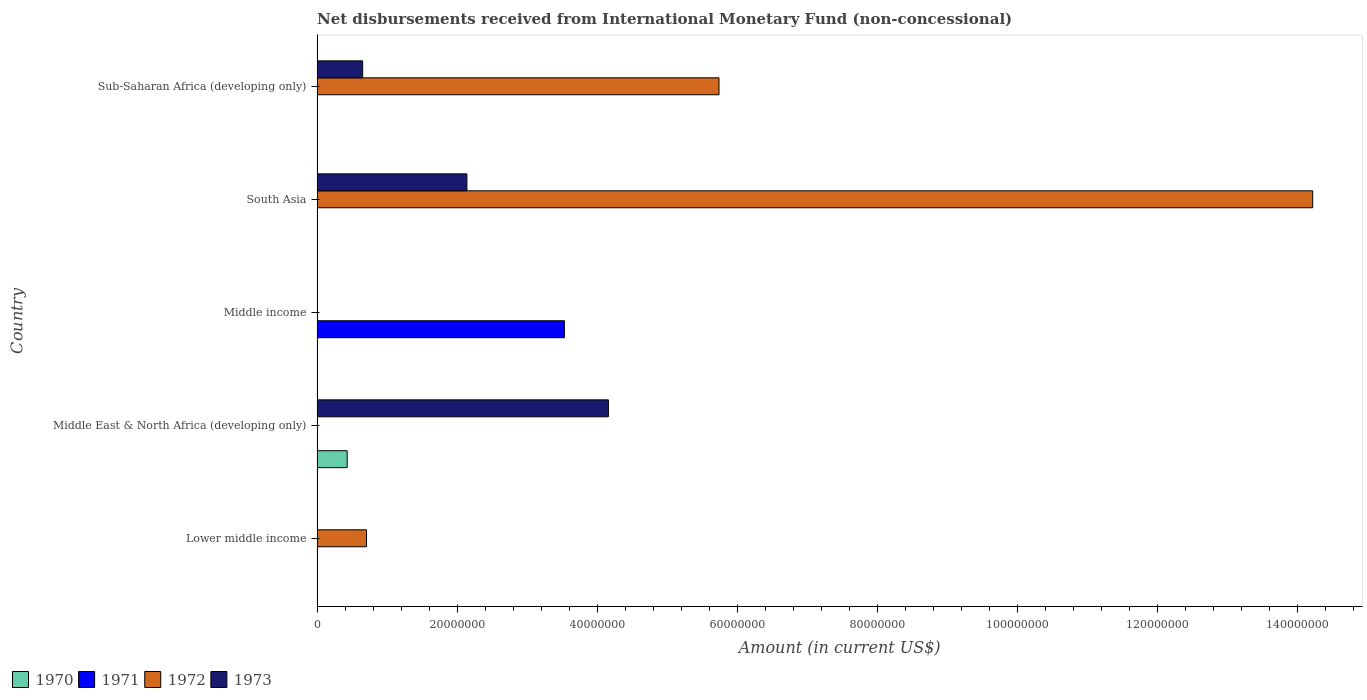How many different coloured bars are there?
Offer a terse response. 4. Are the number of bars per tick equal to the number of legend labels?
Provide a short and direct response. No. Are the number of bars on each tick of the Y-axis equal?
Offer a terse response. No. How many bars are there on the 1st tick from the bottom?
Give a very brief answer. 1. What is the label of the 4th group of bars from the top?
Ensure brevity in your answer.  Middle East & North Africa (developing only). In how many cases, is the number of bars for a given country not equal to the number of legend labels?
Ensure brevity in your answer.  5. What is the amount of disbursements received from International Monetary Fund in 1972 in South Asia?
Your answer should be very brief. 1.42e+08. Across all countries, what is the maximum amount of disbursements received from International Monetary Fund in 1972?
Provide a succinct answer. 1.42e+08. In which country was the amount of disbursements received from International Monetary Fund in 1973 maximum?
Ensure brevity in your answer.  Middle East & North Africa (developing only). What is the total amount of disbursements received from International Monetary Fund in 1972 in the graph?
Give a very brief answer. 2.07e+08. What is the difference between the amount of disbursements received from International Monetary Fund in 1972 in Lower middle income and that in Sub-Saharan Africa (developing only)?
Ensure brevity in your answer.  -5.03e+07. What is the difference between the amount of disbursements received from International Monetary Fund in 1973 in Middle income and the amount of disbursements received from International Monetary Fund in 1970 in Middle East & North Africa (developing only)?
Offer a very short reply. -4.30e+06. What is the average amount of disbursements received from International Monetary Fund in 1970 per country?
Make the answer very short. 8.60e+05. What is the difference between the amount of disbursements received from International Monetary Fund in 1972 and amount of disbursements received from International Monetary Fund in 1973 in South Asia?
Offer a terse response. 1.21e+08. In how many countries, is the amount of disbursements received from International Monetary Fund in 1970 greater than 80000000 US$?
Provide a succinct answer. 0. What is the ratio of the amount of disbursements received from International Monetary Fund in 1972 in Lower middle income to that in Sub-Saharan Africa (developing only)?
Your answer should be compact. 0.12. Is the amount of disbursements received from International Monetary Fund in 1973 in Middle East & North Africa (developing only) less than that in Sub-Saharan Africa (developing only)?
Give a very brief answer. No. What is the difference between the highest and the second highest amount of disbursements received from International Monetary Fund in 1972?
Make the answer very short. 8.48e+07. What is the difference between the highest and the lowest amount of disbursements received from International Monetary Fund in 1972?
Provide a succinct answer. 1.42e+08. In how many countries, is the amount of disbursements received from International Monetary Fund in 1971 greater than the average amount of disbursements received from International Monetary Fund in 1971 taken over all countries?
Provide a succinct answer. 1. Is it the case that in every country, the sum of the amount of disbursements received from International Monetary Fund in 1971 and amount of disbursements received from International Monetary Fund in 1970 is greater than the sum of amount of disbursements received from International Monetary Fund in 1973 and amount of disbursements received from International Monetary Fund in 1972?
Your answer should be compact. No. How many bars are there?
Keep it short and to the point. 8. Are all the bars in the graph horizontal?
Your answer should be very brief. Yes. What is the difference between two consecutive major ticks on the X-axis?
Provide a short and direct response. 2.00e+07. Are the values on the major ticks of X-axis written in scientific E-notation?
Ensure brevity in your answer.  No. Where does the legend appear in the graph?
Your answer should be very brief. Bottom left. How many legend labels are there?
Keep it short and to the point. 4. What is the title of the graph?
Give a very brief answer. Net disbursements received from International Monetary Fund (non-concessional). What is the label or title of the X-axis?
Provide a short and direct response. Amount (in current US$). What is the label or title of the Y-axis?
Your answer should be very brief. Country. What is the Amount (in current US$) of 1970 in Lower middle income?
Offer a very short reply. 0. What is the Amount (in current US$) of 1971 in Lower middle income?
Offer a terse response. 0. What is the Amount (in current US$) in 1972 in Lower middle income?
Offer a terse response. 7.06e+06. What is the Amount (in current US$) in 1970 in Middle East & North Africa (developing only)?
Offer a very short reply. 4.30e+06. What is the Amount (in current US$) of 1972 in Middle East & North Africa (developing only)?
Your answer should be very brief. 0. What is the Amount (in current US$) of 1973 in Middle East & North Africa (developing only)?
Your answer should be very brief. 4.16e+07. What is the Amount (in current US$) of 1970 in Middle income?
Offer a terse response. 0. What is the Amount (in current US$) in 1971 in Middle income?
Make the answer very short. 3.53e+07. What is the Amount (in current US$) in 1970 in South Asia?
Offer a very short reply. 0. What is the Amount (in current US$) in 1971 in South Asia?
Offer a terse response. 0. What is the Amount (in current US$) of 1972 in South Asia?
Ensure brevity in your answer.  1.42e+08. What is the Amount (in current US$) in 1973 in South Asia?
Your response must be concise. 2.14e+07. What is the Amount (in current US$) of 1972 in Sub-Saharan Africa (developing only)?
Provide a succinct answer. 5.74e+07. What is the Amount (in current US$) of 1973 in Sub-Saharan Africa (developing only)?
Keep it short and to the point. 6.51e+06. Across all countries, what is the maximum Amount (in current US$) in 1970?
Provide a succinct answer. 4.30e+06. Across all countries, what is the maximum Amount (in current US$) in 1971?
Keep it short and to the point. 3.53e+07. Across all countries, what is the maximum Amount (in current US$) of 1972?
Give a very brief answer. 1.42e+08. Across all countries, what is the maximum Amount (in current US$) in 1973?
Offer a terse response. 4.16e+07. Across all countries, what is the minimum Amount (in current US$) of 1972?
Offer a terse response. 0. What is the total Amount (in current US$) of 1970 in the graph?
Keep it short and to the point. 4.30e+06. What is the total Amount (in current US$) in 1971 in the graph?
Your response must be concise. 3.53e+07. What is the total Amount (in current US$) in 1972 in the graph?
Keep it short and to the point. 2.07e+08. What is the total Amount (in current US$) of 1973 in the graph?
Offer a very short reply. 6.95e+07. What is the difference between the Amount (in current US$) of 1972 in Lower middle income and that in South Asia?
Offer a terse response. -1.35e+08. What is the difference between the Amount (in current US$) in 1972 in Lower middle income and that in Sub-Saharan Africa (developing only)?
Your answer should be compact. -5.03e+07. What is the difference between the Amount (in current US$) in 1973 in Middle East & North Africa (developing only) and that in South Asia?
Make the answer very short. 2.02e+07. What is the difference between the Amount (in current US$) of 1973 in Middle East & North Africa (developing only) and that in Sub-Saharan Africa (developing only)?
Give a very brief answer. 3.51e+07. What is the difference between the Amount (in current US$) of 1972 in South Asia and that in Sub-Saharan Africa (developing only)?
Ensure brevity in your answer.  8.48e+07. What is the difference between the Amount (in current US$) of 1973 in South Asia and that in Sub-Saharan Africa (developing only)?
Ensure brevity in your answer.  1.49e+07. What is the difference between the Amount (in current US$) of 1972 in Lower middle income and the Amount (in current US$) of 1973 in Middle East & North Africa (developing only)?
Offer a terse response. -3.45e+07. What is the difference between the Amount (in current US$) of 1972 in Lower middle income and the Amount (in current US$) of 1973 in South Asia?
Offer a terse response. -1.43e+07. What is the difference between the Amount (in current US$) in 1972 in Lower middle income and the Amount (in current US$) in 1973 in Sub-Saharan Africa (developing only)?
Your answer should be compact. 5.46e+05. What is the difference between the Amount (in current US$) of 1970 in Middle East & North Africa (developing only) and the Amount (in current US$) of 1971 in Middle income?
Offer a terse response. -3.10e+07. What is the difference between the Amount (in current US$) of 1970 in Middle East & North Africa (developing only) and the Amount (in current US$) of 1972 in South Asia?
Keep it short and to the point. -1.38e+08. What is the difference between the Amount (in current US$) of 1970 in Middle East & North Africa (developing only) and the Amount (in current US$) of 1973 in South Asia?
Provide a succinct answer. -1.71e+07. What is the difference between the Amount (in current US$) in 1970 in Middle East & North Africa (developing only) and the Amount (in current US$) in 1972 in Sub-Saharan Africa (developing only)?
Your answer should be very brief. -5.31e+07. What is the difference between the Amount (in current US$) of 1970 in Middle East & North Africa (developing only) and the Amount (in current US$) of 1973 in Sub-Saharan Africa (developing only)?
Provide a short and direct response. -2.21e+06. What is the difference between the Amount (in current US$) in 1971 in Middle income and the Amount (in current US$) in 1972 in South Asia?
Give a very brief answer. -1.07e+08. What is the difference between the Amount (in current US$) of 1971 in Middle income and the Amount (in current US$) of 1973 in South Asia?
Offer a very short reply. 1.39e+07. What is the difference between the Amount (in current US$) in 1971 in Middle income and the Amount (in current US$) in 1972 in Sub-Saharan Africa (developing only)?
Offer a terse response. -2.21e+07. What is the difference between the Amount (in current US$) in 1971 in Middle income and the Amount (in current US$) in 1973 in Sub-Saharan Africa (developing only)?
Offer a very short reply. 2.88e+07. What is the difference between the Amount (in current US$) of 1972 in South Asia and the Amount (in current US$) of 1973 in Sub-Saharan Africa (developing only)?
Provide a short and direct response. 1.36e+08. What is the average Amount (in current US$) of 1970 per country?
Your answer should be very brief. 8.60e+05. What is the average Amount (in current US$) of 1971 per country?
Your answer should be compact. 7.06e+06. What is the average Amount (in current US$) of 1972 per country?
Provide a succinct answer. 4.13e+07. What is the average Amount (in current US$) in 1973 per country?
Your answer should be very brief. 1.39e+07. What is the difference between the Amount (in current US$) of 1970 and Amount (in current US$) of 1973 in Middle East & North Africa (developing only)?
Make the answer very short. -3.73e+07. What is the difference between the Amount (in current US$) of 1972 and Amount (in current US$) of 1973 in South Asia?
Offer a terse response. 1.21e+08. What is the difference between the Amount (in current US$) in 1972 and Amount (in current US$) in 1973 in Sub-Saharan Africa (developing only)?
Keep it short and to the point. 5.09e+07. What is the ratio of the Amount (in current US$) of 1972 in Lower middle income to that in South Asia?
Keep it short and to the point. 0.05. What is the ratio of the Amount (in current US$) of 1972 in Lower middle income to that in Sub-Saharan Africa (developing only)?
Provide a short and direct response. 0.12. What is the ratio of the Amount (in current US$) in 1973 in Middle East & North Africa (developing only) to that in South Asia?
Your response must be concise. 1.94. What is the ratio of the Amount (in current US$) in 1973 in Middle East & North Africa (developing only) to that in Sub-Saharan Africa (developing only)?
Your answer should be compact. 6.39. What is the ratio of the Amount (in current US$) of 1972 in South Asia to that in Sub-Saharan Africa (developing only)?
Your response must be concise. 2.48. What is the ratio of the Amount (in current US$) in 1973 in South Asia to that in Sub-Saharan Africa (developing only)?
Your answer should be very brief. 3.29. What is the difference between the highest and the second highest Amount (in current US$) of 1972?
Provide a succinct answer. 8.48e+07. What is the difference between the highest and the second highest Amount (in current US$) of 1973?
Offer a very short reply. 2.02e+07. What is the difference between the highest and the lowest Amount (in current US$) of 1970?
Your response must be concise. 4.30e+06. What is the difference between the highest and the lowest Amount (in current US$) in 1971?
Offer a terse response. 3.53e+07. What is the difference between the highest and the lowest Amount (in current US$) in 1972?
Offer a terse response. 1.42e+08. What is the difference between the highest and the lowest Amount (in current US$) of 1973?
Offer a terse response. 4.16e+07. 